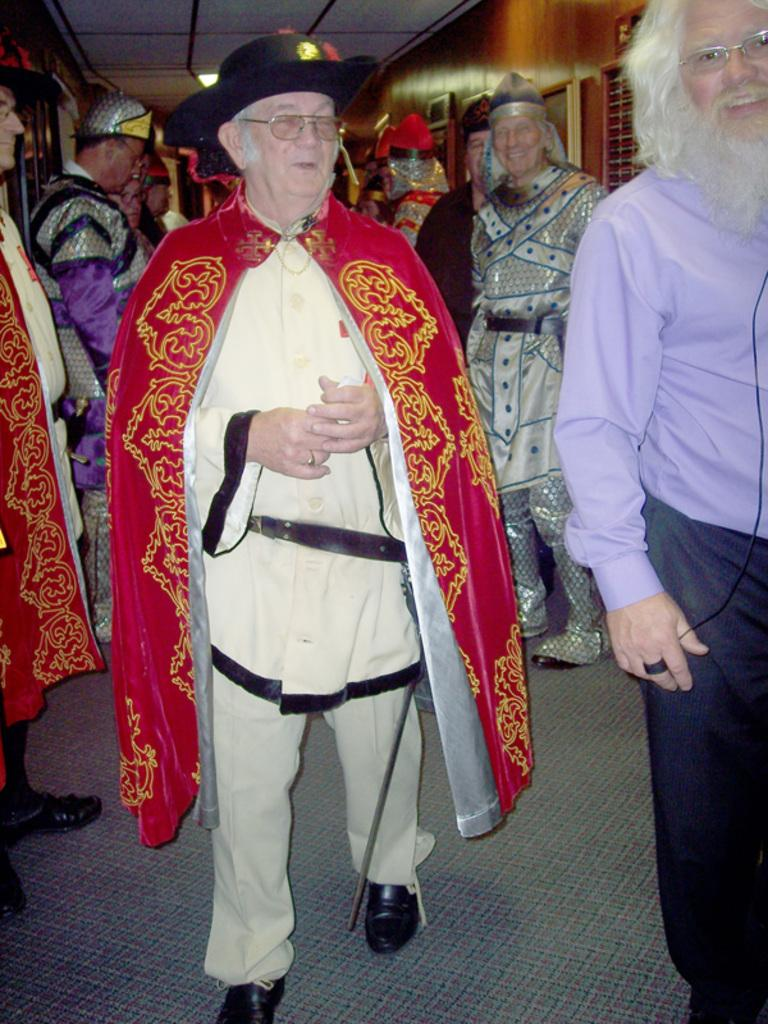What can be seen in the image regarding the people? There are men standing in the image. How are the men dressed? The men are wearing different costumes. What can be observed about the building in the image? There is a white color roof visible in the image, and there are brown walls. What type of meal is being prepared in the image? There is no indication of a meal being prepared in the image. Can you describe the locket that one of the men is wearing in the image? There is no locket visible on any of the men in the image. 